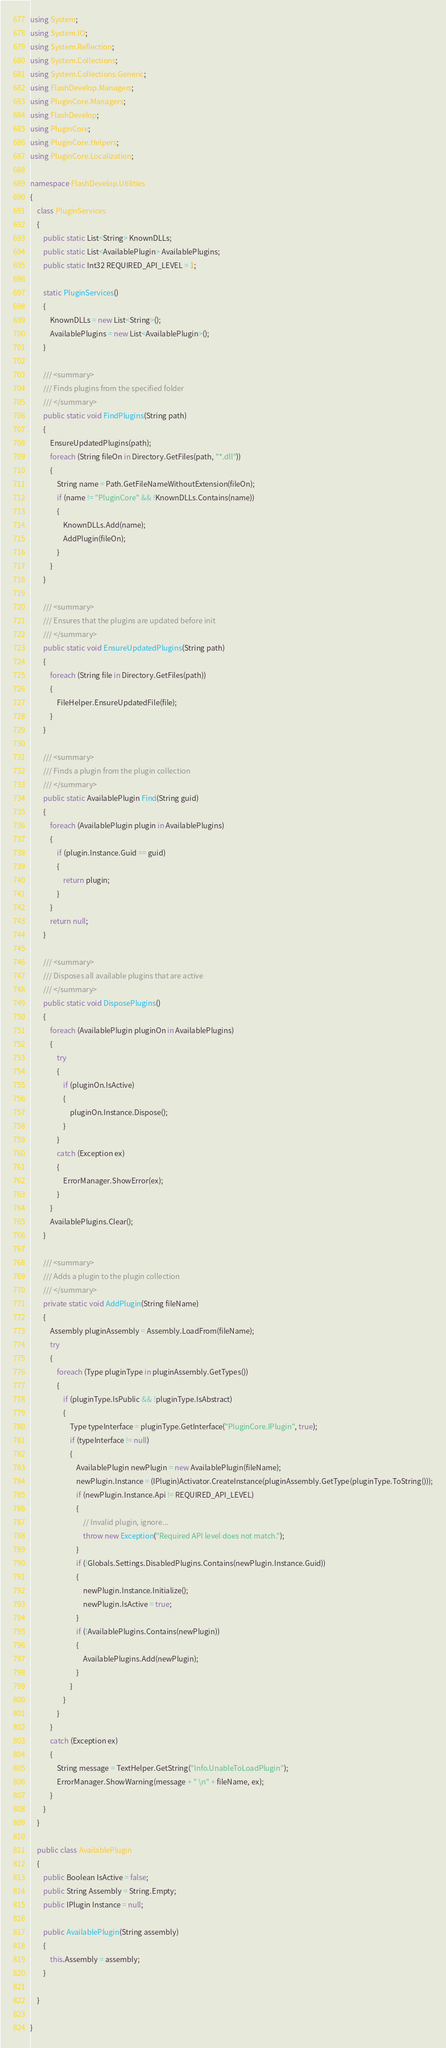<code> <loc_0><loc_0><loc_500><loc_500><_C#_>using System;
using System.IO;
using System.Reflection;
using System.Collections;
using System.Collections.Generic;
using FlashDevelop.Managers;
using PluginCore.Managers;
using FlashDevelop;
using PluginCore;
using PluginCore.Helpers;
using PluginCore.Localization;

namespace FlashDevelop.Utilities 
{
	class PluginServices
	{
        public static List<String> KnownDLLs;
        public static List<AvailablePlugin> AvailablePlugins;
        public static Int32 REQUIRED_API_LEVEL = 1;
        
        static PluginServices()
        {
            KnownDLLs = new List<String>();
            AvailablePlugins = new List<AvailablePlugin>();
        }

		/// <summary>
		/// Finds plugins from the specified folder
		/// </summary>
        public static void FindPlugins(String path)
		{
            EnsureUpdatedPlugins(path);
            foreach (String fileOn in Directory.GetFiles(path, "*.dll"))
			{
                String name = Path.GetFileNameWithoutExtension(fileOn);
                if (name != "PluginCore" && !KnownDLLs.Contains(name))
                {
                    KnownDLLs.Add(name);
                    AddPlugin(fileOn);
                }
			}
		}

        /// <summary>
        /// Ensures that the plugins are updated before init
        /// </summary>
        public static void EnsureUpdatedPlugins(String path)
        {
            foreach (String file in Directory.GetFiles(path))
            {
                FileHelper.EnsureUpdatedFile(file);
            }
        }

        /// <summary>
        /// Finds a plugin from the plugin collection
        /// </summary>
        public static AvailablePlugin Find(String guid)
        {
            foreach (AvailablePlugin plugin in AvailablePlugins)
            {
                if (plugin.Instance.Guid == guid)
                {
                    return plugin;
                }
            }
            return null;
        }

		/// <summary>
		/// Disposes all available plugins that are active
		/// </summary>
        public static void DisposePlugins()
		{
			foreach (AvailablePlugin pluginOn in AvailablePlugins)
			{
				try
                {
                    if (pluginOn.IsActive)
                    {
                        pluginOn.Instance.Dispose();
                    }
				} 
				catch (Exception ex)
				{
                    ErrorManager.ShowError(ex);
				}
			}
			AvailablePlugins.Clear();
		}
		
		/// <summary>
		/// Adds a plugin to the plugin collection
		/// </summary>
        private static void AddPlugin(String fileName)
		{
			Assembly pluginAssembly = Assembly.LoadFrom(fileName);
            try
            {
                foreach (Type pluginType in pluginAssembly.GetTypes())
                {
                    if (pluginType.IsPublic && !pluginType.IsAbstract)
                    {
                        Type typeInterface = pluginType.GetInterface("PluginCore.IPlugin", true);
                        if (typeInterface != null)
                        {
                            AvailablePlugin newPlugin = new AvailablePlugin(fileName);
                            newPlugin.Instance = (IPlugin)Activator.CreateInstance(pluginAssembly.GetType(pluginType.ToString()));
                            if (newPlugin.Instance.Api != REQUIRED_API_LEVEL)
                            {
                                // Invalid plugin, ignore...
                                throw new Exception("Required API level does not match.");
                            }
                            if (!Globals.Settings.DisabledPlugins.Contains(newPlugin.Instance.Guid))
                            {
                                newPlugin.Instance.Initialize();
                                newPlugin.IsActive = true;
                            }
                            if (!AvailablePlugins.Contains(newPlugin))
                            {
                                AvailablePlugins.Add(newPlugin);
                            }
                        }
                    }
                }
            }
            catch (Exception ex)
            {
                String message = TextHelper.GetString("Info.UnableToLoadPlugin");
                ErrorManager.ShowWarning(message + " \n" + fileName, ex);
            }
		}
	}

	public class AvailablePlugin
	{
        public Boolean IsActive = false;
        public String Assembly = String.Empty;
        public IPlugin Instance = null;

        public AvailablePlugin(String assembly)
        {
            this.Assembly = assembly;
        }
		
	}
	
}
</code> 